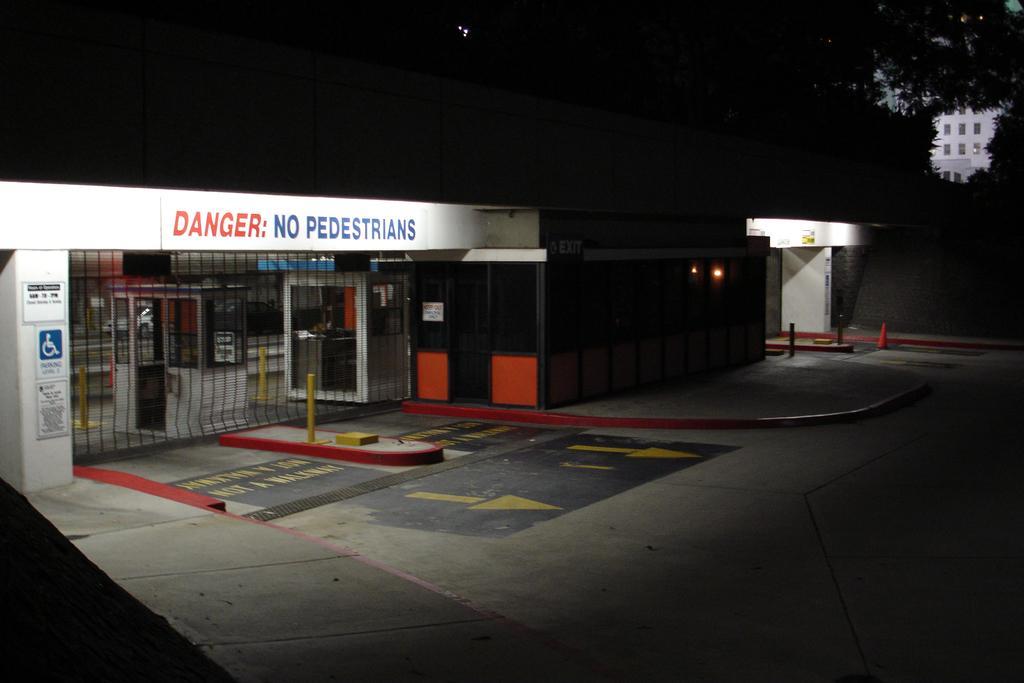Could you give a brief overview of what you see in this image? In this image I can see the building and I can see some boards to the building. I can also see the lights to the building. In-front of the building I can see the poles and the traffic cone. To the right I can see an another building and the trees. And there is a black background. 